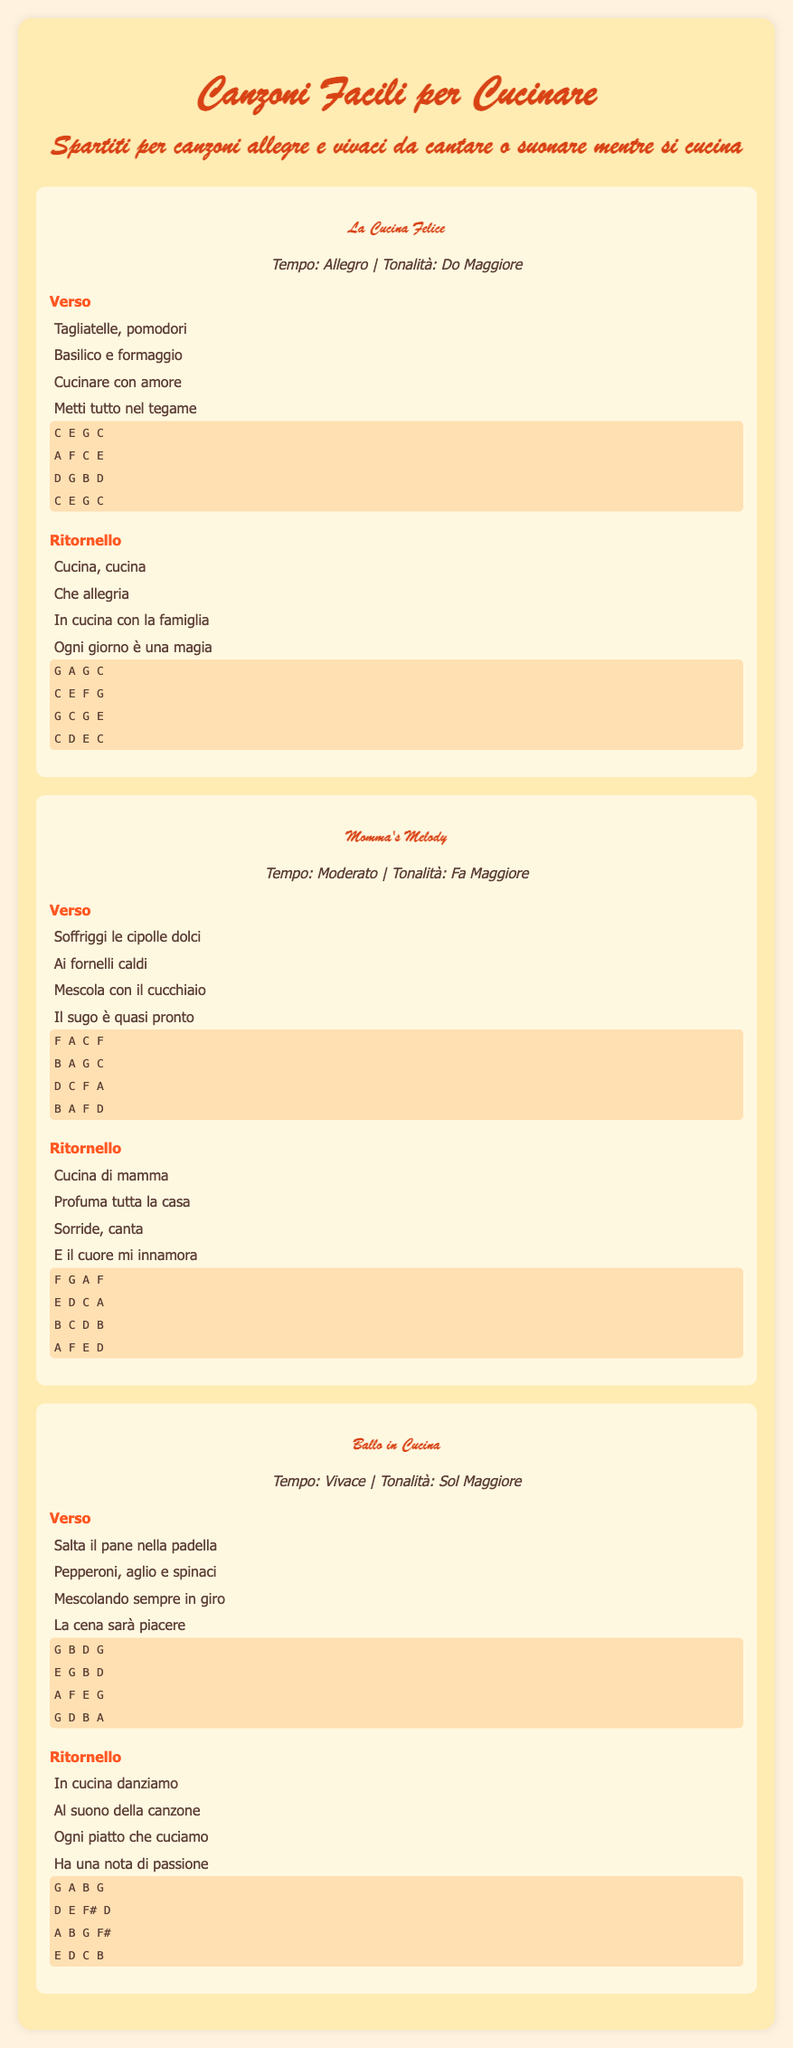What is the title of the first song? The title of the first song is found in the document's song section.
Answer: La Cucina Felice What tempo is "Momma's Melody"? The tempo indicates the speed of the song, listed in the song's info section.
Answer: Moderato Which key is "Ballo in Cucina" written in? The key signature is specified in the song's information section.
Answer: Sol Maggiore How many songs are included in the document? The total number of songs can be counted from the song sections present in the document.
Answer: Three What ingredient is mentioned in the lyrics of "La Cucina Felice"? The lyrics include specific food items associated with cooking, as shown in the document.
Answer: Pomodori Which song features the lyrics "Cucina di mamma"? The song title can be identified through the lyrics mentioned in the document.
Answer: Momma's Melody What is the theme of the songs in this document? The theme can be inferred from the title of the document and the lyrics of the songs.
Answer: Cooking What type of music is this sheet music intended for? The document specifies the type of music through its title and descriptions of the songs.
Answer: Easy Cooking Songs 